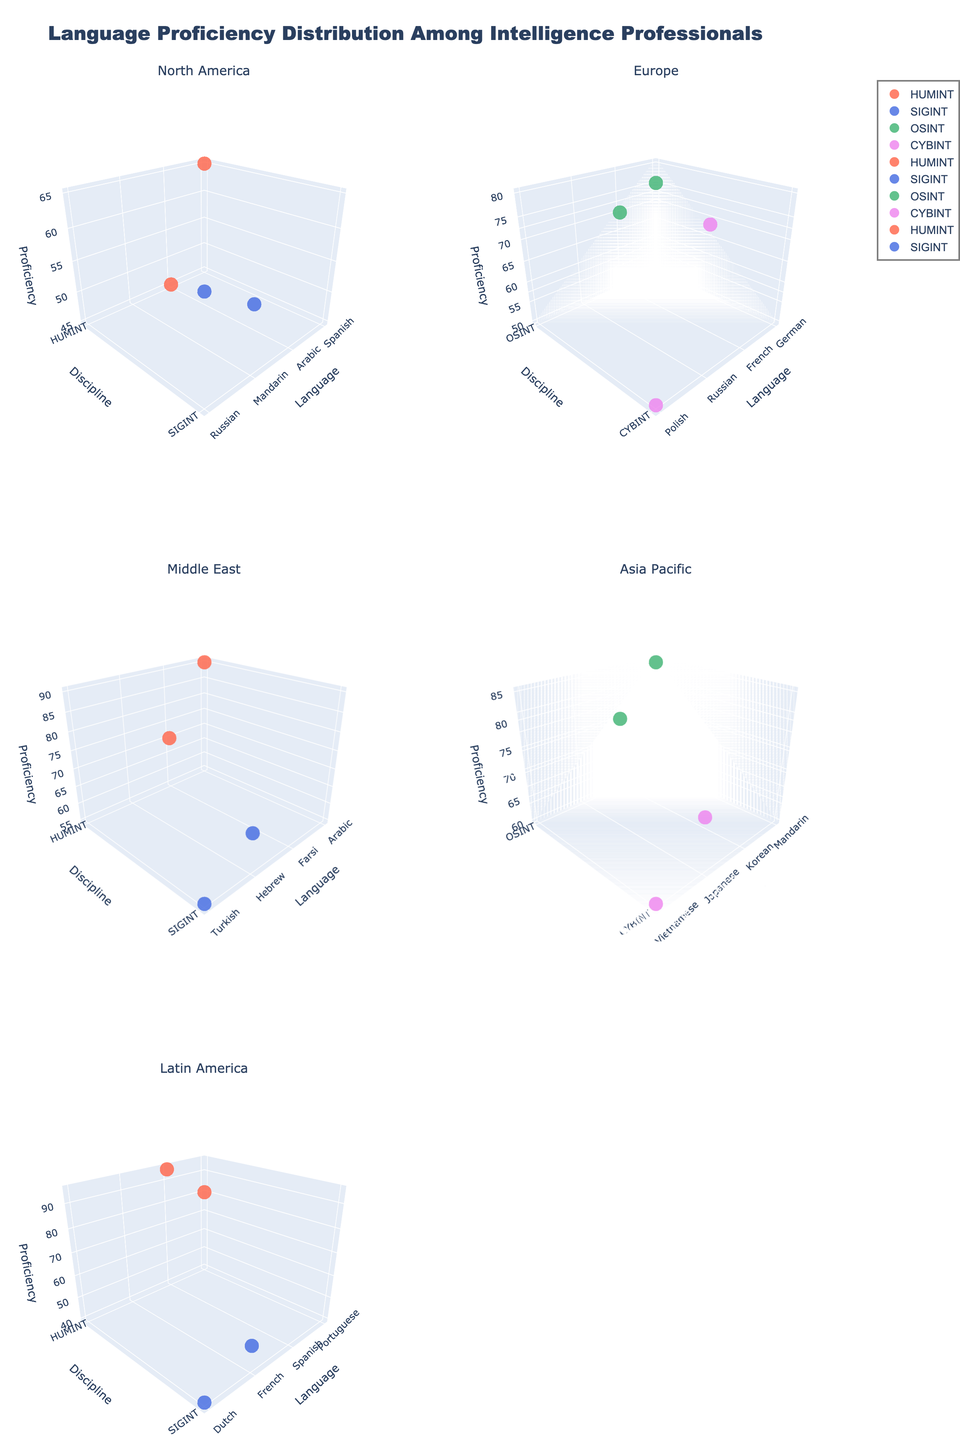what is the title of the figure? The title of the figure is located at the top and provides an overall description of what the figure is demonstrating.
Answer: Language Proficiency Distribution Among Intelligence Professionals What regions are compared in the figure? The subplot titles will denote the different regions being compared in the respective 3D plots.
Answer: North America, Europe, Middle East, Asia Pacific, Latin America Which language and proficiency combination has the maximum proficiency in the Middle East region? By examining the Middle East subplot, identify the data point with the highest 'Proficiency' value and note the associated 'Language'.
Answer: Arabic, 90 How many intelligence disciplines are represented in the Asia Pacific region's subplot? Look at the 'Discipline' axis on the subplot for Asia Pacific to count the unique disciplines.
Answer: 2 Compare the proficiency levels of the SIGINT discipline for North America and Latin America. Which region has the higher maximum proficiency? In the respective subplots for North America and Latin America, identify the highest proficiency value for the SIGINT discipline and compare them.
Answer: North America, 60 Identify the intelligence discipline with the most languages represented in the Europe region. Examine the subplot for Europe and count the number of unique languages under each discipline.
Answer: OSINT, 2 (German, French) In the Asia Pacific subplot, which language has the higher proficiency in the CYBINT discipline? Compare the proficiency values of the languages listed under CYBINT in the Asia Pacific subplot.
Answer: Japanese, 70 Which region exhibits the highest proficiency for Russian in the context of the CYBINT discipline? Look across the relevant subplots and identify the proficiency value for Russian under the CYBINT discipline in each applicable region.
Answer: Europe, 80 